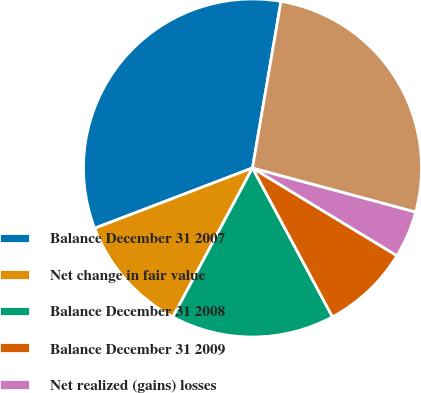Convert chart. <chart><loc_0><loc_0><loc_500><loc_500><pie_chart><fcel>Balance December 31 2007<fcel>Net change in fair value<fcel>Balance December 31 2008<fcel>Balance December 31 2009<fcel>Net realized (gains) losses<fcel>Balance December 31 2010<nl><fcel>33.5%<fcel>11.38%<fcel>15.66%<fcel>8.47%<fcel>4.49%<fcel>26.5%<nl></chart> 